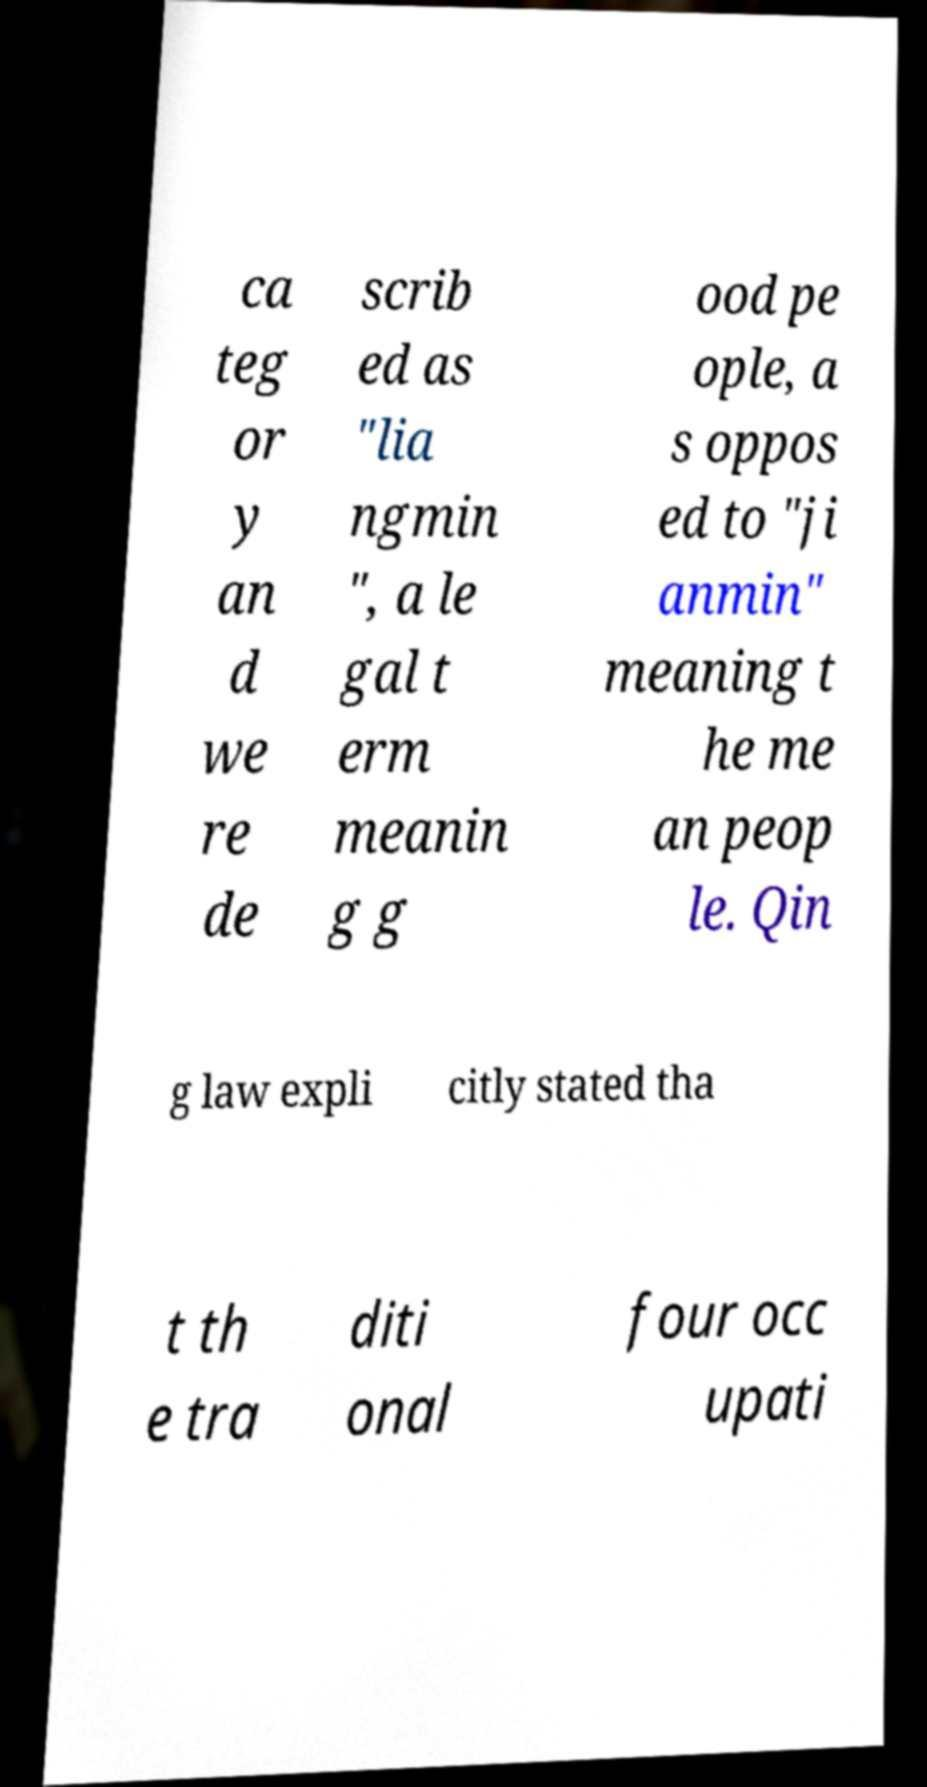Could you assist in decoding the text presented in this image and type it out clearly? ca teg or y an d we re de scrib ed as "lia ngmin ", a le gal t erm meanin g g ood pe ople, a s oppos ed to "ji anmin" meaning t he me an peop le. Qin g law expli citly stated tha t th e tra diti onal four occ upati 